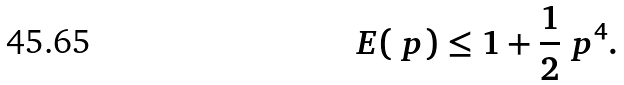<formula> <loc_0><loc_0><loc_500><loc_500>E ( \ p ) \leq 1 + \frac { 1 } { 2 } \ p ^ { 4 } .</formula> 